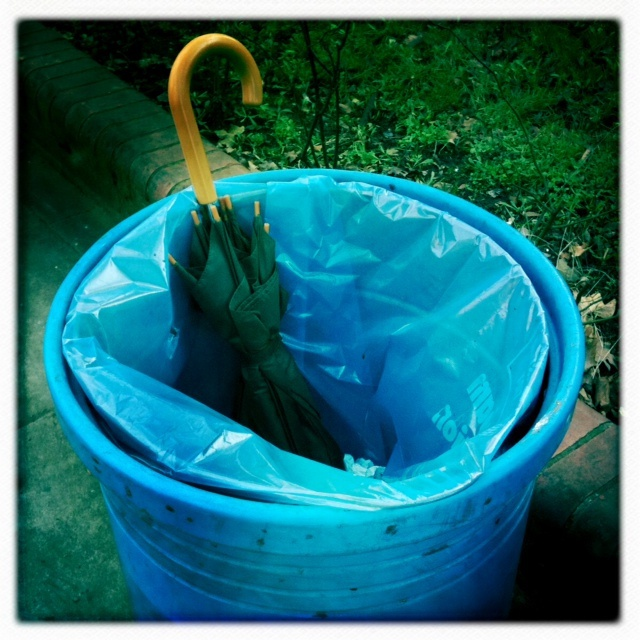Describe the objects in this image and their specific colors. I can see a umbrella in white, black, teal, darkgreen, and olive tones in this image. 